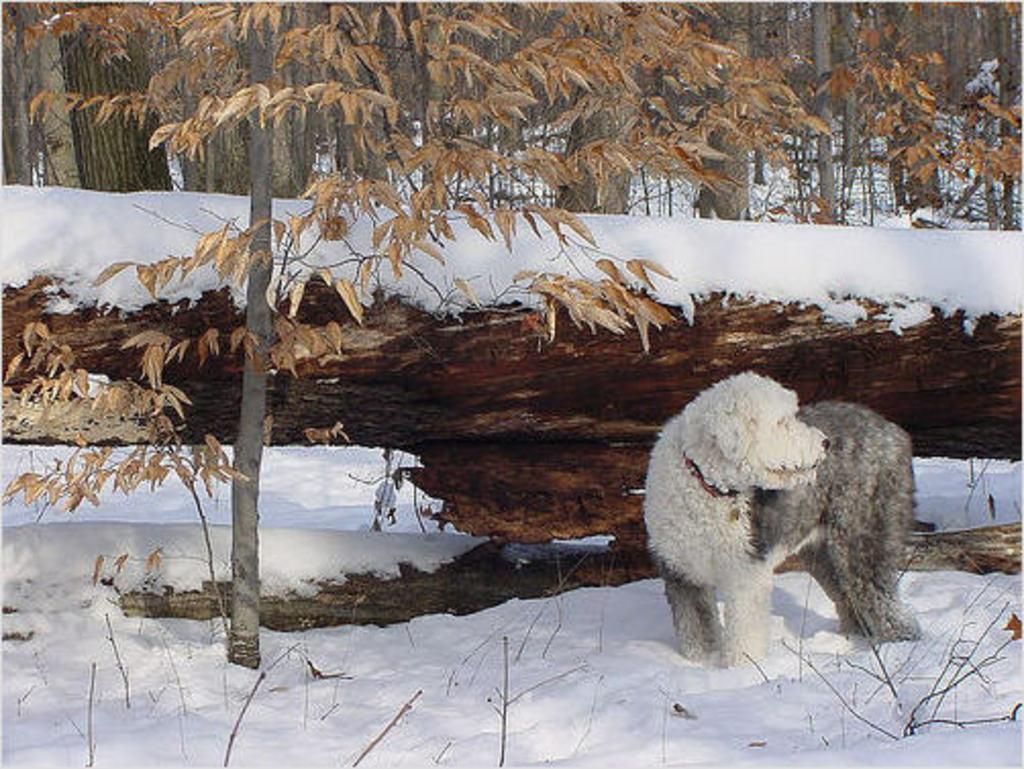What can be seen in the foreground of the picture? In the foreground of the picture, there are twigs, a plant, a dog, soil, and snow. What is the dog doing in the foreground of the picture? The dog's actions are not specified, but it is present in the foreground of the picture. What is visible in the background of the picture? There are trees in the background of the picture. What type of terrain is depicted in the foreground of the picture? The presence of twigs, soil, and snow suggests that the terrain is a snowy area with vegetation. How far away is the volleyball from the dog in the image? There is no volleyball present in the image, so it cannot be determined how far away it might be from the dog. 